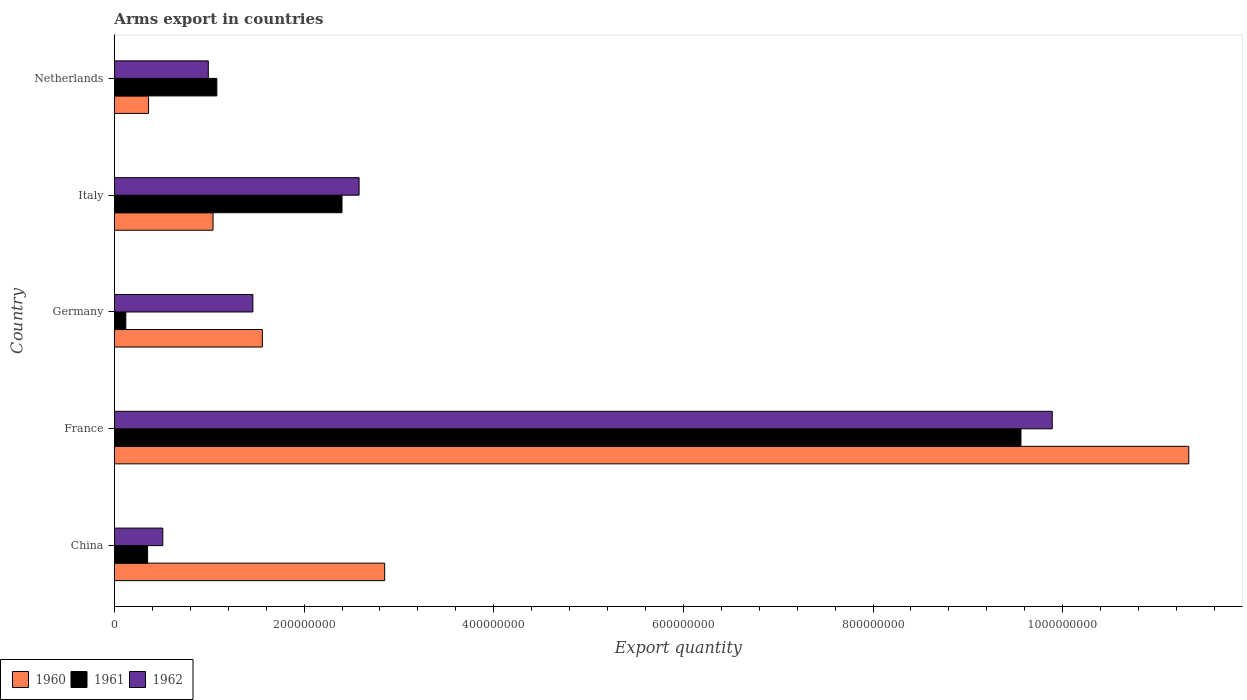Are the number of bars per tick equal to the number of legend labels?
Your response must be concise. Yes. Are the number of bars on each tick of the Y-axis equal?
Keep it short and to the point. Yes. How many bars are there on the 3rd tick from the top?
Your answer should be compact. 3. What is the total arms export in 1961 in Netherlands?
Provide a short and direct response. 1.08e+08. Across all countries, what is the maximum total arms export in 1960?
Make the answer very short. 1.13e+09. Across all countries, what is the minimum total arms export in 1960?
Make the answer very short. 3.60e+07. In which country was the total arms export in 1962 minimum?
Offer a terse response. China. What is the total total arms export in 1962 in the graph?
Give a very brief answer. 1.54e+09. What is the difference between the total arms export in 1962 in China and that in France?
Offer a very short reply. -9.38e+08. What is the difference between the total arms export in 1962 in Germany and the total arms export in 1961 in France?
Offer a very short reply. -8.10e+08. What is the average total arms export in 1961 per country?
Ensure brevity in your answer.  2.70e+08. What is the difference between the total arms export in 1961 and total arms export in 1960 in Germany?
Offer a very short reply. -1.44e+08. In how many countries, is the total arms export in 1960 greater than 720000000 ?
Your response must be concise. 1. What is the ratio of the total arms export in 1961 in China to that in Germany?
Your answer should be compact. 2.92. Is the total arms export in 1962 in France less than that in Germany?
Provide a short and direct response. No. What is the difference between the highest and the second highest total arms export in 1962?
Your response must be concise. 7.31e+08. What is the difference between the highest and the lowest total arms export in 1961?
Provide a short and direct response. 9.44e+08. What does the 1st bar from the top in France represents?
Offer a terse response. 1962. Is it the case that in every country, the sum of the total arms export in 1962 and total arms export in 1961 is greater than the total arms export in 1960?
Provide a short and direct response. No. Are all the bars in the graph horizontal?
Provide a short and direct response. Yes. How many countries are there in the graph?
Your response must be concise. 5. Does the graph contain any zero values?
Your response must be concise. No. Where does the legend appear in the graph?
Make the answer very short. Bottom left. How are the legend labels stacked?
Offer a terse response. Horizontal. What is the title of the graph?
Your response must be concise. Arms export in countries. What is the label or title of the X-axis?
Provide a succinct answer. Export quantity. What is the label or title of the Y-axis?
Keep it short and to the point. Country. What is the Export quantity of 1960 in China?
Give a very brief answer. 2.85e+08. What is the Export quantity in 1961 in China?
Offer a very short reply. 3.50e+07. What is the Export quantity in 1962 in China?
Provide a succinct answer. 5.10e+07. What is the Export quantity of 1960 in France?
Provide a succinct answer. 1.13e+09. What is the Export quantity of 1961 in France?
Ensure brevity in your answer.  9.56e+08. What is the Export quantity of 1962 in France?
Provide a short and direct response. 9.89e+08. What is the Export quantity of 1960 in Germany?
Your answer should be compact. 1.56e+08. What is the Export quantity in 1962 in Germany?
Offer a very short reply. 1.46e+08. What is the Export quantity of 1960 in Italy?
Your answer should be very brief. 1.04e+08. What is the Export quantity of 1961 in Italy?
Ensure brevity in your answer.  2.40e+08. What is the Export quantity in 1962 in Italy?
Your answer should be very brief. 2.58e+08. What is the Export quantity of 1960 in Netherlands?
Give a very brief answer. 3.60e+07. What is the Export quantity of 1961 in Netherlands?
Offer a very short reply. 1.08e+08. What is the Export quantity of 1962 in Netherlands?
Your answer should be very brief. 9.90e+07. Across all countries, what is the maximum Export quantity in 1960?
Make the answer very short. 1.13e+09. Across all countries, what is the maximum Export quantity in 1961?
Give a very brief answer. 9.56e+08. Across all countries, what is the maximum Export quantity of 1962?
Offer a very short reply. 9.89e+08. Across all countries, what is the minimum Export quantity in 1960?
Provide a short and direct response. 3.60e+07. Across all countries, what is the minimum Export quantity in 1962?
Ensure brevity in your answer.  5.10e+07. What is the total Export quantity in 1960 in the graph?
Your answer should be compact. 1.71e+09. What is the total Export quantity in 1961 in the graph?
Keep it short and to the point. 1.35e+09. What is the total Export quantity in 1962 in the graph?
Make the answer very short. 1.54e+09. What is the difference between the Export quantity of 1960 in China and that in France?
Your answer should be compact. -8.48e+08. What is the difference between the Export quantity of 1961 in China and that in France?
Keep it short and to the point. -9.21e+08. What is the difference between the Export quantity in 1962 in China and that in France?
Provide a short and direct response. -9.38e+08. What is the difference between the Export quantity of 1960 in China and that in Germany?
Offer a terse response. 1.29e+08. What is the difference between the Export quantity in 1961 in China and that in Germany?
Your answer should be compact. 2.30e+07. What is the difference between the Export quantity in 1962 in China and that in Germany?
Offer a very short reply. -9.50e+07. What is the difference between the Export quantity of 1960 in China and that in Italy?
Offer a very short reply. 1.81e+08. What is the difference between the Export quantity in 1961 in China and that in Italy?
Your answer should be very brief. -2.05e+08. What is the difference between the Export quantity of 1962 in China and that in Italy?
Provide a succinct answer. -2.07e+08. What is the difference between the Export quantity in 1960 in China and that in Netherlands?
Your answer should be compact. 2.49e+08. What is the difference between the Export quantity in 1961 in China and that in Netherlands?
Your response must be concise. -7.30e+07. What is the difference between the Export quantity in 1962 in China and that in Netherlands?
Ensure brevity in your answer.  -4.80e+07. What is the difference between the Export quantity of 1960 in France and that in Germany?
Your answer should be compact. 9.77e+08. What is the difference between the Export quantity of 1961 in France and that in Germany?
Offer a terse response. 9.44e+08. What is the difference between the Export quantity of 1962 in France and that in Germany?
Make the answer very short. 8.43e+08. What is the difference between the Export quantity of 1960 in France and that in Italy?
Provide a short and direct response. 1.03e+09. What is the difference between the Export quantity of 1961 in France and that in Italy?
Keep it short and to the point. 7.16e+08. What is the difference between the Export quantity in 1962 in France and that in Italy?
Provide a short and direct response. 7.31e+08. What is the difference between the Export quantity of 1960 in France and that in Netherlands?
Make the answer very short. 1.10e+09. What is the difference between the Export quantity of 1961 in France and that in Netherlands?
Provide a short and direct response. 8.48e+08. What is the difference between the Export quantity in 1962 in France and that in Netherlands?
Keep it short and to the point. 8.90e+08. What is the difference between the Export quantity in 1960 in Germany and that in Italy?
Keep it short and to the point. 5.20e+07. What is the difference between the Export quantity of 1961 in Germany and that in Italy?
Your response must be concise. -2.28e+08. What is the difference between the Export quantity in 1962 in Germany and that in Italy?
Offer a terse response. -1.12e+08. What is the difference between the Export quantity of 1960 in Germany and that in Netherlands?
Your answer should be compact. 1.20e+08. What is the difference between the Export quantity of 1961 in Germany and that in Netherlands?
Offer a very short reply. -9.60e+07. What is the difference between the Export quantity of 1962 in Germany and that in Netherlands?
Your answer should be compact. 4.70e+07. What is the difference between the Export quantity in 1960 in Italy and that in Netherlands?
Keep it short and to the point. 6.80e+07. What is the difference between the Export quantity in 1961 in Italy and that in Netherlands?
Provide a succinct answer. 1.32e+08. What is the difference between the Export quantity in 1962 in Italy and that in Netherlands?
Offer a very short reply. 1.59e+08. What is the difference between the Export quantity in 1960 in China and the Export quantity in 1961 in France?
Make the answer very short. -6.71e+08. What is the difference between the Export quantity of 1960 in China and the Export quantity of 1962 in France?
Provide a short and direct response. -7.04e+08. What is the difference between the Export quantity in 1961 in China and the Export quantity in 1962 in France?
Offer a very short reply. -9.54e+08. What is the difference between the Export quantity of 1960 in China and the Export quantity of 1961 in Germany?
Make the answer very short. 2.73e+08. What is the difference between the Export quantity of 1960 in China and the Export quantity of 1962 in Germany?
Make the answer very short. 1.39e+08. What is the difference between the Export quantity of 1961 in China and the Export quantity of 1962 in Germany?
Keep it short and to the point. -1.11e+08. What is the difference between the Export quantity in 1960 in China and the Export quantity in 1961 in Italy?
Provide a succinct answer. 4.50e+07. What is the difference between the Export quantity of 1960 in China and the Export quantity of 1962 in Italy?
Keep it short and to the point. 2.70e+07. What is the difference between the Export quantity in 1961 in China and the Export quantity in 1962 in Italy?
Make the answer very short. -2.23e+08. What is the difference between the Export quantity of 1960 in China and the Export quantity of 1961 in Netherlands?
Give a very brief answer. 1.77e+08. What is the difference between the Export quantity in 1960 in China and the Export quantity in 1962 in Netherlands?
Provide a succinct answer. 1.86e+08. What is the difference between the Export quantity in 1961 in China and the Export quantity in 1962 in Netherlands?
Your answer should be very brief. -6.40e+07. What is the difference between the Export quantity of 1960 in France and the Export quantity of 1961 in Germany?
Make the answer very short. 1.12e+09. What is the difference between the Export quantity of 1960 in France and the Export quantity of 1962 in Germany?
Keep it short and to the point. 9.87e+08. What is the difference between the Export quantity in 1961 in France and the Export quantity in 1962 in Germany?
Keep it short and to the point. 8.10e+08. What is the difference between the Export quantity in 1960 in France and the Export quantity in 1961 in Italy?
Provide a short and direct response. 8.93e+08. What is the difference between the Export quantity of 1960 in France and the Export quantity of 1962 in Italy?
Give a very brief answer. 8.75e+08. What is the difference between the Export quantity of 1961 in France and the Export quantity of 1962 in Italy?
Offer a very short reply. 6.98e+08. What is the difference between the Export quantity in 1960 in France and the Export quantity in 1961 in Netherlands?
Offer a very short reply. 1.02e+09. What is the difference between the Export quantity of 1960 in France and the Export quantity of 1962 in Netherlands?
Provide a succinct answer. 1.03e+09. What is the difference between the Export quantity of 1961 in France and the Export quantity of 1962 in Netherlands?
Give a very brief answer. 8.57e+08. What is the difference between the Export quantity of 1960 in Germany and the Export quantity of 1961 in Italy?
Make the answer very short. -8.40e+07. What is the difference between the Export quantity in 1960 in Germany and the Export quantity in 1962 in Italy?
Ensure brevity in your answer.  -1.02e+08. What is the difference between the Export quantity in 1961 in Germany and the Export quantity in 1962 in Italy?
Make the answer very short. -2.46e+08. What is the difference between the Export quantity of 1960 in Germany and the Export quantity of 1961 in Netherlands?
Provide a short and direct response. 4.80e+07. What is the difference between the Export quantity in 1960 in Germany and the Export quantity in 1962 in Netherlands?
Offer a very short reply. 5.70e+07. What is the difference between the Export quantity in 1961 in Germany and the Export quantity in 1962 in Netherlands?
Your answer should be compact. -8.70e+07. What is the difference between the Export quantity of 1961 in Italy and the Export quantity of 1962 in Netherlands?
Offer a terse response. 1.41e+08. What is the average Export quantity in 1960 per country?
Your answer should be very brief. 3.43e+08. What is the average Export quantity in 1961 per country?
Your answer should be very brief. 2.70e+08. What is the average Export quantity in 1962 per country?
Keep it short and to the point. 3.09e+08. What is the difference between the Export quantity of 1960 and Export quantity of 1961 in China?
Provide a succinct answer. 2.50e+08. What is the difference between the Export quantity in 1960 and Export quantity in 1962 in China?
Your response must be concise. 2.34e+08. What is the difference between the Export quantity of 1961 and Export quantity of 1962 in China?
Make the answer very short. -1.60e+07. What is the difference between the Export quantity in 1960 and Export quantity in 1961 in France?
Ensure brevity in your answer.  1.77e+08. What is the difference between the Export quantity in 1960 and Export quantity in 1962 in France?
Offer a terse response. 1.44e+08. What is the difference between the Export quantity in 1961 and Export quantity in 1962 in France?
Make the answer very short. -3.30e+07. What is the difference between the Export quantity in 1960 and Export quantity in 1961 in Germany?
Your response must be concise. 1.44e+08. What is the difference between the Export quantity in 1960 and Export quantity in 1962 in Germany?
Give a very brief answer. 1.00e+07. What is the difference between the Export quantity of 1961 and Export quantity of 1962 in Germany?
Provide a succinct answer. -1.34e+08. What is the difference between the Export quantity in 1960 and Export quantity in 1961 in Italy?
Ensure brevity in your answer.  -1.36e+08. What is the difference between the Export quantity in 1960 and Export quantity in 1962 in Italy?
Your answer should be compact. -1.54e+08. What is the difference between the Export quantity in 1961 and Export quantity in 1962 in Italy?
Your answer should be compact. -1.80e+07. What is the difference between the Export quantity of 1960 and Export quantity of 1961 in Netherlands?
Your answer should be very brief. -7.20e+07. What is the difference between the Export quantity in 1960 and Export quantity in 1962 in Netherlands?
Provide a succinct answer. -6.30e+07. What is the difference between the Export quantity of 1961 and Export quantity of 1962 in Netherlands?
Provide a succinct answer. 9.00e+06. What is the ratio of the Export quantity in 1960 in China to that in France?
Keep it short and to the point. 0.25. What is the ratio of the Export quantity in 1961 in China to that in France?
Your answer should be compact. 0.04. What is the ratio of the Export quantity in 1962 in China to that in France?
Make the answer very short. 0.05. What is the ratio of the Export quantity in 1960 in China to that in Germany?
Provide a short and direct response. 1.83. What is the ratio of the Export quantity of 1961 in China to that in Germany?
Offer a very short reply. 2.92. What is the ratio of the Export quantity in 1962 in China to that in Germany?
Ensure brevity in your answer.  0.35. What is the ratio of the Export quantity of 1960 in China to that in Italy?
Provide a succinct answer. 2.74. What is the ratio of the Export quantity of 1961 in China to that in Italy?
Offer a very short reply. 0.15. What is the ratio of the Export quantity in 1962 in China to that in Italy?
Make the answer very short. 0.2. What is the ratio of the Export quantity in 1960 in China to that in Netherlands?
Provide a short and direct response. 7.92. What is the ratio of the Export quantity of 1961 in China to that in Netherlands?
Ensure brevity in your answer.  0.32. What is the ratio of the Export quantity of 1962 in China to that in Netherlands?
Your answer should be very brief. 0.52. What is the ratio of the Export quantity of 1960 in France to that in Germany?
Provide a succinct answer. 7.26. What is the ratio of the Export quantity of 1961 in France to that in Germany?
Give a very brief answer. 79.67. What is the ratio of the Export quantity of 1962 in France to that in Germany?
Provide a succinct answer. 6.77. What is the ratio of the Export quantity in 1960 in France to that in Italy?
Provide a succinct answer. 10.89. What is the ratio of the Export quantity in 1961 in France to that in Italy?
Ensure brevity in your answer.  3.98. What is the ratio of the Export quantity in 1962 in France to that in Italy?
Your response must be concise. 3.83. What is the ratio of the Export quantity in 1960 in France to that in Netherlands?
Provide a short and direct response. 31.47. What is the ratio of the Export quantity of 1961 in France to that in Netherlands?
Your response must be concise. 8.85. What is the ratio of the Export quantity in 1962 in France to that in Netherlands?
Offer a terse response. 9.99. What is the ratio of the Export quantity of 1960 in Germany to that in Italy?
Offer a very short reply. 1.5. What is the ratio of the Export quantity in 1962 in Germany to that in Italy?
Give a very brief answer. 0.57. What is the ratio of the Export quantity of 1960 in Germany to that in Netherlands?
Your response must be concise. 4.33. What is the ratio of the Export quantity of 1961 in Germany to that in Netherlands?
Provide a succinct answer. 0.11. What is the ratio of the Export quantity of 1962 in Germany to that in Netherlands?
Provide a short and direct response. 1.47. What is the ratio of the Export quantity of 1960 in Italy to that in Netherlands?
Provide a succinct answer. 2.89. What is the ratio of the Export quantity in 1961 in Italy to that in Netherlands?
Provide a succinct answer. 2.22. What is the ratio of the Export quantity of 1962 in Italy to that in Netherlands?
Give a very brief answer. 2.61. What is the difference between the highest and the second highest Export quantity of 1960?
Offer a terse response. 8.48e+08. What is the difference between the highest and the second highest Export quantity of 1961?
Keep it short and to the point. 7.16e+08. What is the difference between the highest and the second highest Export quantity of 1962?
Ensure brevity in your answer.  7.31e+08. What is the difference between the highest and the lowest Export quantity in 1960?
Offer a very short reply. 1.10e+09. What is the difference between the highest and the lowest Export quantity of 1961?
Offer a very short reply. 9.44e+08. What is the difference between the highest and the lowest Export quantity of 1962?
Ensure brevity in your answer.  9.38e+08. 